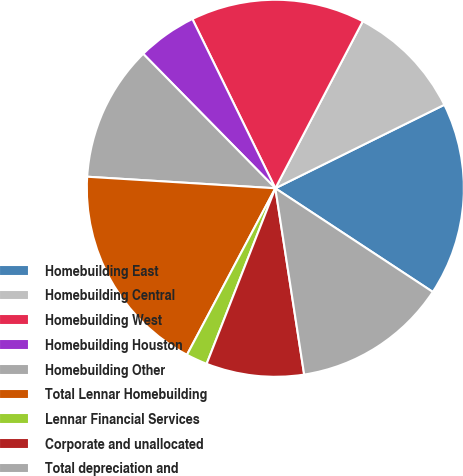<chart> <loc_0><loc_0><loc_500><loc_500><pie_chart><fcel>Homebuilding East<fcel>Homebuilding Central<fcel>Homebuilding West<fcel>Homebuilding Houston<fcel>Homebuilding Other<fcel>Total Lennar Homebuilding<fcel>Lennar Financial Services<fcel>Corporate and unallocated<fcel>Total depreciation and<nl><fcel>16.57%<fcel>10.02%<fcel>14.93%<fcel>5.11%<fcel>11.66%<fcel>18.21%<fcel>1.83%<fcel>8.38%<fcel>13.29%<nl></chart> 